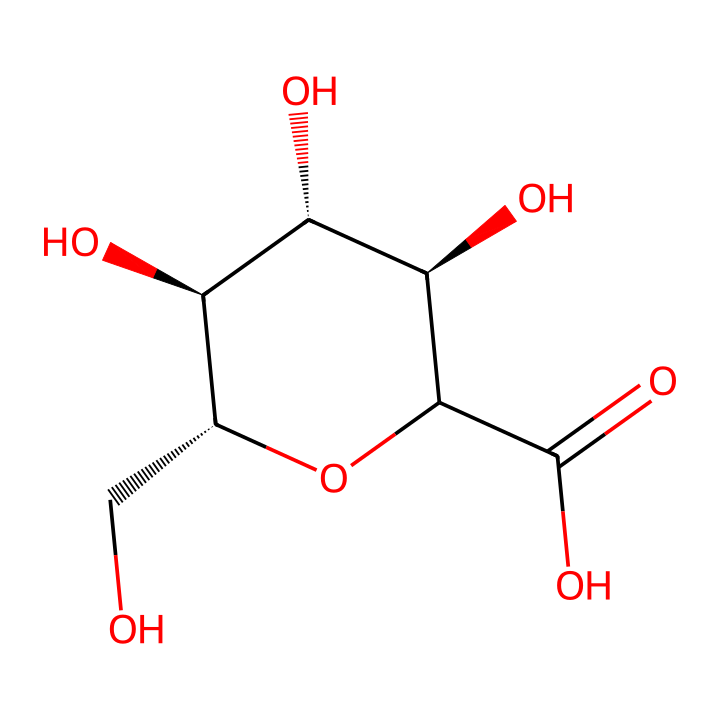What is the molecular formula of gum arabic? To determine the molecular formula, one must count the number of each type of atom present in the SMILES representation. The structure shows carbon (C), hydrogen (H), and oxygen (O) atoms. There are 6 carbon atoms, 10 hydrogen atoms, and 6 oxygen atoms, leading to the formula C6H10O6.
Answer: C6H10O6 How many carbon atoms are in the chemical structure? By examining the SMILES representation, each 'C' in the molecule indicates a carbon atom. Counting these, we find a total of 6 carbon atoms.
Answer: 6 Is gum arabic a natural or synthetic compound? Considering that gum arabic is derived from the sap of acacia trees, it is classified as a natural compound rather than synthetic.
Answer: natural What type of bonding is primarily present in gum arabic as indicated by the structure? The SMILES representation reveals many single bonds between carbon and other atoms, as well as some hydroxyl (OH) groups, indicating that gum arabic is primarily characterized by covalent bonding, which is typical for organic compounds.
Answer: covalent What functional groups are present in gum arabic? In the structure, there are hydroxyl (-OH) groups attached to the carbon atoms, which are indicative of alcohol functionality. Additionally, there is a carboxylic acid (-COOH) group indicated by the O=C(O) part of the structure. Therefore, the main functional groups are alcohol and carboxylic acid.
Answer: alcohol and carboxylic acid Which property of gum arabic makes it suitable for use as a stabilizer in paints and inks? The hydroxyl groups and the overall polysaccharide structure of gum arabic provide it with emulsifying and stabilizing properties, allowing it to help mix water and oil components in paints and inks.
Answer: emulsifying and stabilizing properties 